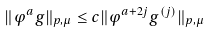Convert formula to latex. <formula><loc_0><loc_0><loc_500><loc_500>\| \varphi ^ { a } g \| _ { p , \mu } \leq c \| \varphi ^ { a + 2 j } g ^ { ( j ) } \| _ { p , \mu }</formula> 